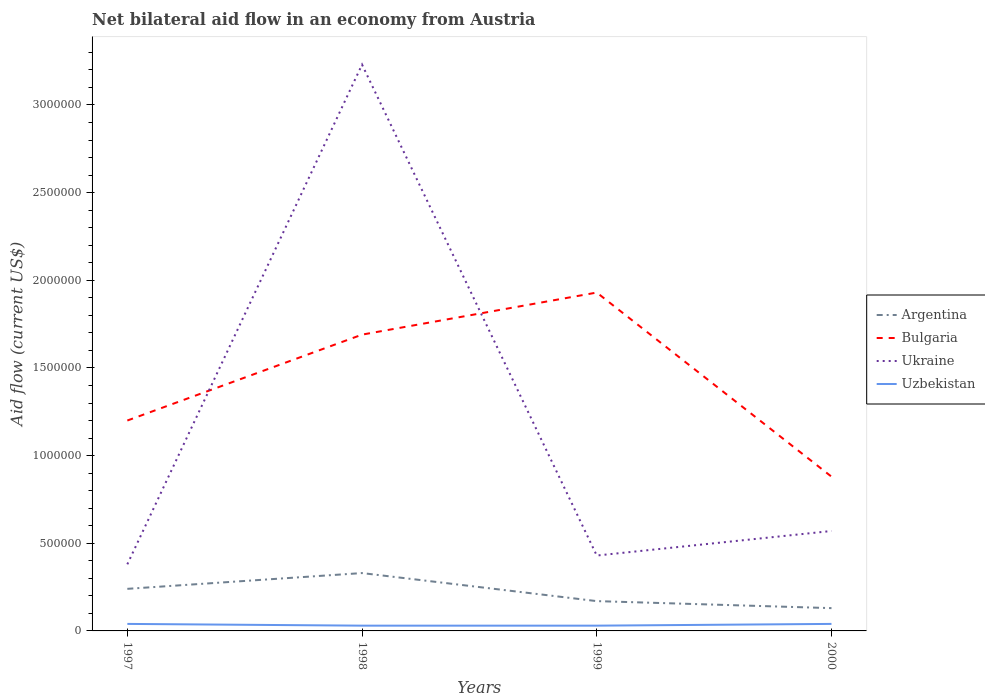Is the number of lines equal to the number of legend labels?
Give a very brief answer. Yes. Across all years, what is the maximum net bilateral aid flow in Argentina?
Your response must be concise. 1.30e+05. In which year was the net bilateral aid flow in Ukraine maximum?
Provide a short and direct response. 1997. Is the net bilateral aid flow in Uzbekistan strictly greater than the net bilateral aid flow in Bulgaria over the years?
Offer a terse response. Yes. How many lines are there?
Your response must be concise. 4. How many years are there in the graph?
Offer a very short reply. 4. What is the difference between two consecutive major ticks on the Y-axis?
Give a very brief answer. 5.00e+05. Are the values on the major ticks of Y-axis written in scientific E-notation?
Make the answer very short. No. Does the graph contain grids?
Offer a very short reply. No. What is the title of the graph?
Keep it short and to the point. Net bilateral aid flow in an economy from Austria. What is the Aid flow (current US$) in Argentina in 1997?
Give a very brief answer. 2.40e+05. What is the Aid flow (current US$) of Bulgaria in 1997?
Your response must be concise. 1.20e+06. What is the Aid flow (current US$) in Ukraine in 1997?
Make the answer very short. 3.80e+05. What is the Aid flow (current US$) of Bulgaria in 1998?
Offer a very short reply. 1.69e+06. What is the Aid flow (current US$) of Ukraine in 1998?
Keep it short and to the point. 3.23e+06. What is the Aid flow (current US$) in Uzbekistan in 1998?
Offer a very short reply. 3.00e+04. What is the Aid flow (current US$) of Argentina in 1999?
Provide a succinct answer. 1.70e+05. What is the Aid flow (current US$) in Bulgaria in 1999?
Offer a terse response. 1.93e+06. What is the Aid flow (current US$) of Argentina in 2000?
Your answer should be compact. 1.30e+05. What is the Aid flow (current US$) in Bulgaria in 2000?
Your answer should be very brief. 8.80e+05. What is the Aid flow (current US$) in Ukraine in 2000?
Offer a terse response. 5.70e+05. Across all years, what is the maximum Aid flow (current US$) in Bulgaria?
Give a very brief answer. 1.93e+06. Across all years, what is the maximum Aid flow (current US$) in Ukraine?
Offer a terse response. 3.23e+06. Across all years, what is the maximum Aid flow (current US$) of Uzbekistan?
Your answer should be very brief. 4.00e+04. Across all years, what is the minimum Aid flow (current US$) in Bulgaria?
Your answer should be very brief. 8.80e+05. What is the total Aid flow (current US$) in Argentina in the graph?
Keep it short and to the point. 8.70e+05. What is the total Aid flow (current US$) of Bulgaria in the graph?
Offer a very short reply. 5.70e+06. What is the total Aid flow (current US$) in Ukraine in the graph?
Keep it short and to the point. 4.61e+06. What is the difference between the Aid flow (current US$) of Bulgaria in 1997 and that in 1998?
Offer a very short reply. -4.90e+05. What is the difference between the Aid flow (current US$) of Ukraine in 1997 and that in 1998?
Your answer should be very brief. -2.85e+06. What is the difference between the Aid flow (current US$) of Bulgaria in 1997 and that in 1999?
Offer a very short reply. -7.30e+05. What is the difference between the Aid flow (current US$) in Ukraine in 1997 and that in 2000?
Provide a succinct answer. -1.90e+05. What is the difference between the Aid flow (current US$) in Uzbekistan in 1997 and that in 2000?
Provide a short and direct response. 0. What is the difference between the Aid flow (current US$) in Argentina in 1998 and that in 1999?
Offer a very short reply. 1.60e+05. What is the difference between the Aid flow (current US$) in Bulgaria in 1998 and that in 1999?
Keep it short and to the point. -2.40e+05. What is the difference between the Aid flow (current US$) in Ukraine in 1998 and that in 1999?
Make the answer very short. 2.80e+06. What is the difference between the Aid flow (current US$) in Uzbekistan in 1998 and that in 1999?
Provide a succinct answer. 0. What is the difference between the Aid flow (current US$) in Bulgaria in 1998 and that in 2000?
Make the answer very short. 8.10e+05. What is the difference between the Aid flow (current US$) of Ukraine in 1998 and that in 2000?
Offer a very short reply. 2.66e+06. What is the difference between the Aid flow (current US$) of Uzbekistan in 1998 and that in 2000?
Offer a terse response. -10000. What is the difference between the Aid flow (current US$) in Argentina in 1999 and that in 2000?
Ensure brevity in your answer.  4.00e+04. What is the difference between the Aid flow (current US$) of Bulgaria in 1999 and that in 2000?
Your answer should be very brief. 1.05e+06. What is the difference between the Aid flow (current US$) of Ukraine in 1999 and that in 2000?
Keep it short and to the point. -1.40e+05. What is the difference between the Aid flow (current US$) of Argentina in 1997 and the Aid flow (current US$) of Bulgaria in 1998?
Your answer should be compact. -1.45e+06. What is the difference between the Aid flow (current US$) in Argentina in 1997 and the Aid flow (current US$) in Ukraine in 1998?
Your answer should be very brief. -2.99e+06. What is the difference between the Aid flow (current US$) of Argentina in 1997 and the Aid flow (current US$) of Uzbekistan in 1998?
Give a very brief answer. 2.10e+05. What is the difference between the Aid flow (current US$) of Bulgaria in 1997 and the Aid flow (current US$) of Ukraine in 1998?
Offer a terse response. -2.03e+06. What is the difference between the Aid flow (current US$) of Bulgaria in 1997 and the Aid flow (current US$) of Uzbekistan in 1998?
Provide a short and direct response. 1.17e+06. What is the difference between the Aid flow (current US$) of Argentina in 1997 and the Aid flow (current US$) of Bulgaria in 1999?
Ensure brevity in your answer.  -1.69e+06. What is the difference between the Aid flow (current US$) of Argentina in 1997 and the Aid flow (current US$) of Ukraine in 1999?
Make the answer very short. -1.90e+05. What is the difference between the Aid flow (current US$) in Argentina in 1997 and the Aid flow (current US$) in Uzbekistan in 1999?
Offer a very short reply. 2.10e+05. What is the difference between the Aid flow (current US$) in Bulgaria in 1997 and the Aid flow (current US$) in Ukraine in 1999?
Provide a short and direct response. 7.70e+05. What is the difference between the Aid flow (current US$) of Bulgaria in 1997 and the Aid flow (current US$) of Uzbekistan in 1999?
Ensure brevity in your answer.  1.17e+06. What is the difference between the Aid flow (current US$) in Ukraine in 1997 and the Aid flow (current US$) in Uzbekistan in 1999?
Offer a very short reply. 3.50e+05. What is the difference between the Aid flow (current US$) in Argentina in 1997 and the Aid flow (current US$) in Bulgaria in 2000?
Your response must be concise. -6.40e+05. What is the difference between the Aid flow (current US$) in Argentina in 1997 and the Aid flow (current US$) in Ukraine in 2000?
Ensure brevity in your answer.  -3.30e+05. What is the difference between the Aid flow (current US$) of Argentina in 1997 and the Aid flow (current US$) of Uzbekistan in 2000?
Your answer should be compact. 2.00e+05. What is the difference between the Aid flow (current US$) of Bulgaria in 1997 and the Aid flow (current US$) of Ukraine in 2000?
Provide a short and direct response. 6.30e+05. What is the difference between the Aid flow (current US$) in Bulgaria in 1997 and the Aid flow (current US$) in Uzbekistan in 2000?
Provide a succinct answer. 1.16e+06. What is the difference between the Aid flow (current US$) in Argentina in 1998 and the Aid flow (current US$) in Bulgaria in 1999?
Your response must be concise. -1.60e+06. What is the difference between the Aid flow (current US$) of Argentina in 1998 and the Aid flow (current US$) of Ukraine in 1999?
Offer a terse response. -1.00e+05. What is the difference between the Aid flow (current US$) of Argentina in 1998 and the Aid flow (current US$) of Uzbekistan in 1999?
Ensure brevity in your answer.  3.00e+05. What is the difference between the Aid flow (current US$) of Bulgaria in 1998 and the Aid flow (current US$) of Ukraine in 1999?
Make the answer very short. 1.26e+06. What is the difference between the Aid flow (current US$) of Bulgaria in 1998 and the Aid flow (current US$) of Uzbekistan in 1999?
Offer a very short reply. 1.66e+06. What is the difference between the Aid flow (current US$) in Ukraine in 1998 and the Aid flow (current US$) in Uzbekistan in 1999?
Offer a terse response. 3.20e+06. What is the difference between the Aid flow (current US$) in Argentina in 1998 and the Aid flow (current US$) in Bulgaria in 2000?
Offer a very short reply. -5.50e+05. What is the difference between the Aid flow (current US$) in Argentina in 1998 and the Aid flow (current US$) in Ukraine in 2000?
Your response must be concise. -2.40e+05. What is the difference between the Aid flow (current US$) of Argentina in 1998 and the Aid flow (current US$) of Uzbekistan in 2000?
Provide a succinct answer. 2.90e+05. What is the difference between the Aid flow (current US$) of Bulgaria in 1998 and the Aid flow (current US$) of Ukraine in 2000?
Provide a short and direct response. 1.12e+06. What is the difference between the Aid flow (current US$) in Bulgaria in 1998 and the Aid flow (current US$) in Uzbekistan in 2000?
Your answer should be compact. 1.65e+06. What is the difference between the Aid flow (current US$) in Ukraine in 1998 and the Aid flow (current US$) in Uzbekistan in 2000?
Give a very brief answer. 3.19e+06. What is the difference between the Aid flow (current US$) in Argentina in 1999 and the Aid flow (current US$) in Bulgaria in 2000?
Make the answer very short. -7.10e+05. What is the difference between the Aid flow (current US$) of Argentina in 1999 and the Aid flow (current US$) of Ukraine in 2000?
Your answer should be very brief. -4.00e+05. What is the difference between the Aid flow (current US$) in Bulgaria in 1999 and the Aid flow (current US$) in Ukraine in 2000?
Ensure brevity in your answer.  1.36e+06. What is the difference between the Aid flow (current US$) in Bulgaria in 1999 and the Aid flow (current US$) in Uzbekistan in 2000?
Keep it short and to the point. 1.89e+06. What is the difference between the Aid flow (current US$) in Ukraine in 1999 and the Aid flow (current US$) in Uzbekistan in 2000?
Offer a very short reply. 3.90e+05. What is the average Aid flow (current US$) in Argentina per year?
Your answer should be very brief. 2.18e+05. What is the average Aid flow (current US$) in Bulgaria per year?
Offer a terse response. 1.42e+06. What is the average Aid flow (current US$) in Ukraine per year?
Your response must be concise. 1.15e+06. What is the average Aid flow (current US$) of Uzbekistan per year?
Provide a short and direct response. 3.50e+04. In the year 1997, what is the difference between the Aid flow (current US$) in Argentina and Aid flow (current US$) in Bulgaria?
Give a very brief answer. -9.60e+05. In the year 1997, what is the difference between the Aid flow (current US$) in Bulgaria and Aid flow (current US$) in Ukraine?
Offer a very short reply. 8.20e+05. In the year 1997, what is the difference between the Aid flow (current US$) of Bulgaria and Aid flow (current US$) of Uzbekistan?
Your answer should be compact. 1.16e+06. In the year 1998, what is the difference between the Aid flow (current US$) of Argentina and Aid flow (current US$) of Bulgaria?
Your response must be concise. -1.36e+06. In the year 1998, what is the difference between the Aid flow (current US$) of Argentina and Aid flow (current US$) of Ukraine?
Give a very brief answer. -2.90e+06. In the year 1998, what is the difference between the Aid flow (current US$) in Bulgaria and Aid flow (current US$) in Ukraine?
Your answer should be very brief. -1.54e+06. In the year 1998, what is the difference between the Aid flow (current US$) of Bulgaria and Aid flow (current US$) of Uzbekistan?
Offer a very short reply. 1.66e+06. In the year 1998, what is the difference between the Aid flow (current US$) in Ukraine and Aid flow (current US$) in Uzbekistan?
Offer a terse response. 3.20e+06. In the year 1999, what is the difference between the Aid flow (current US$) in Argentina and Aid flow (current US$) in Bulgaria?
Provide a short and direct response. -1.76e+06. In the year 1999, what is the difference between the Aid flow (current US$) of Argentina and Aid flow (current US$) of Ukraine?
Your answer should be very brief. -2.60e+05. In the year 1999, what is the difference between the Aid flow (current US$) in Bulgaria and Aid flow (current US$) in Ukraine?
Your response must be concise. 1.50e+06. In the year 1999, what is the difference between the Aid flow (current US$) of Bulgaria and Aid flow (current US$) of Uzbekistan?
Offer a terse response. 1.90e+06. In the year 2000, what is the difference between the Aid flow (current US$) of Argentina and Aid flow (current US$) of Bulgaria?
Your response must be concise. -7.50e+05. In the year 2000, what is the difference between the Aid flow (current US$) of Argentina and Aid flow (current US$) of Ukraine?
Your answer should be compact. -4.40e+05. In the year 2000, what is the difference between the Aid flow (current US$) of Argentina and Aid flow (current US$) of Uzbekistan?
Provide a short and direct response. 9.00e+04. In the year 2000, what is the difference between the Aid flow (current US$) of Bulgaria and Aid flow (current US$) of Ukraine?
Ensure brevity in your answer.  3.10e+05. In the year 2000, what is the difference between the Aid flow (current US$) of Bulgaria and Aid flow (current US$) of Uzbekistan?
Provide a short and direct response. 8.40e+05. In the year 2000, what is the difference between the Aid flow (current US$) of Ukraine and Aid flow (current US$) of Uzbekistan?
Give a very brief answer. 5.30e+05. What is the ratio of the Aid flow (current US$) in Argentina in 1997 to that in 1998?
Keep it short and to the point. 0.73. What is the ratio of the Aid flow (current US$) of Bulgaria in 1997 to that in 1998?
Your answer should be very brief. 0.71. What is the ratio of the Aid flow (current US$) in Ukraine in 1997 to that in 1998?
Offer a terse response. 0.12. What is the ratio of the Aid flow (current US$) in Argentina in 1997 to that in 1999?
Your answer should be very brief. 1.41. What is the ratio of the Aid flow (current US$) of Bulgaria in 1997 to that in 1999?
Offer a very short reply. 0.62. What is the ratio of the Aid flow (current US$) in Ukraine in 1997 to that in 1999?
Make the answer very short. 0.88. What is the ratio of the Aid flow (current US$) in Uzbekistan in 1997 to that in 1999?
Offer a terse response. 1.33. What is the ratio of the Aid flow (current US$) of Argentina in 1997 to that in 2000?
Give a very brief answer. 1.85. What is the ratio of the Aid flow (current US$) in Bulgaria in 1997 to that in 2000?
Your answer should be very brief. 1.36. What is the ratio of the Aid flow (current US$) of Argentina in 1998 to that in 1999?
Keep it short and to the point. 1.94. What is the ratio of the Aid flow (current US$) in Bulgaria in 1998 to that in 1999?
Keep it short and to the point. 0.88. What is the ratio of the Aid flow (current US$) in Ukraine in 1998 to that in 1999?
Keep it short and to the point. 7.51. What is the ratio of the Aid flow (current US$) in Uzbekistan in 1998 to that in 1999?
Provide a short and direct response. 1. What is the ratio of the Aid flow (current US$) in Argentina in 1998 to that in 2000?
Provide a short and direct response. 2.54. What is the ratio of the Aid flow (current US$) of Bulgaria in 1998 to that in 2000?
Provide a succinct answer. 1.92. What is the ratio of the Aid flow (current US$) in Ukraine in 1998 to that in 2000?
Provide a succinct answer. 5.67. What is the ratio of the Aid flow (current US$) of Uzbekistan in 1998 to that in 2000?
Ensure brevity in your answer.  0.75. What is the ratio of the Aid flow (current US$) in Argentina in 1999 to that in 2000?
Keep it short and to the point. 1.31. What is the ratio of the Aid flow (current US$) in Bulgaria in 1999 to that in 2000?
Give a very brief answer. 2.19. What is the ratio of the Aid flow (current US$) in Ukraine in 1999 to that in 2000?
Keep it short and to the point. 0.75. What is the ratio of the Aid flow (current US$) in Uzbekistan in 1999 to that in 2000?
Provide a short and direct response. 0.75. What is the difference between the highest and the second highest Aid flow (current US$) of Bulgaria?
Offer a very short reply. 2.40e+05. What is the difference between the highest and the second highest Aid flow (current US$) in Ukraine?
Provide a succinct answer. 2.66e+06. What is the difference between the highest and the lowest Aid flow (current US$) in Bulgaria?
Your answer should be very brief. 1.05e+06. What is the difference between the highest and the lowest Aid flow (current US$) in Ukraine?
Offer a terse response. 2.85e+06. 